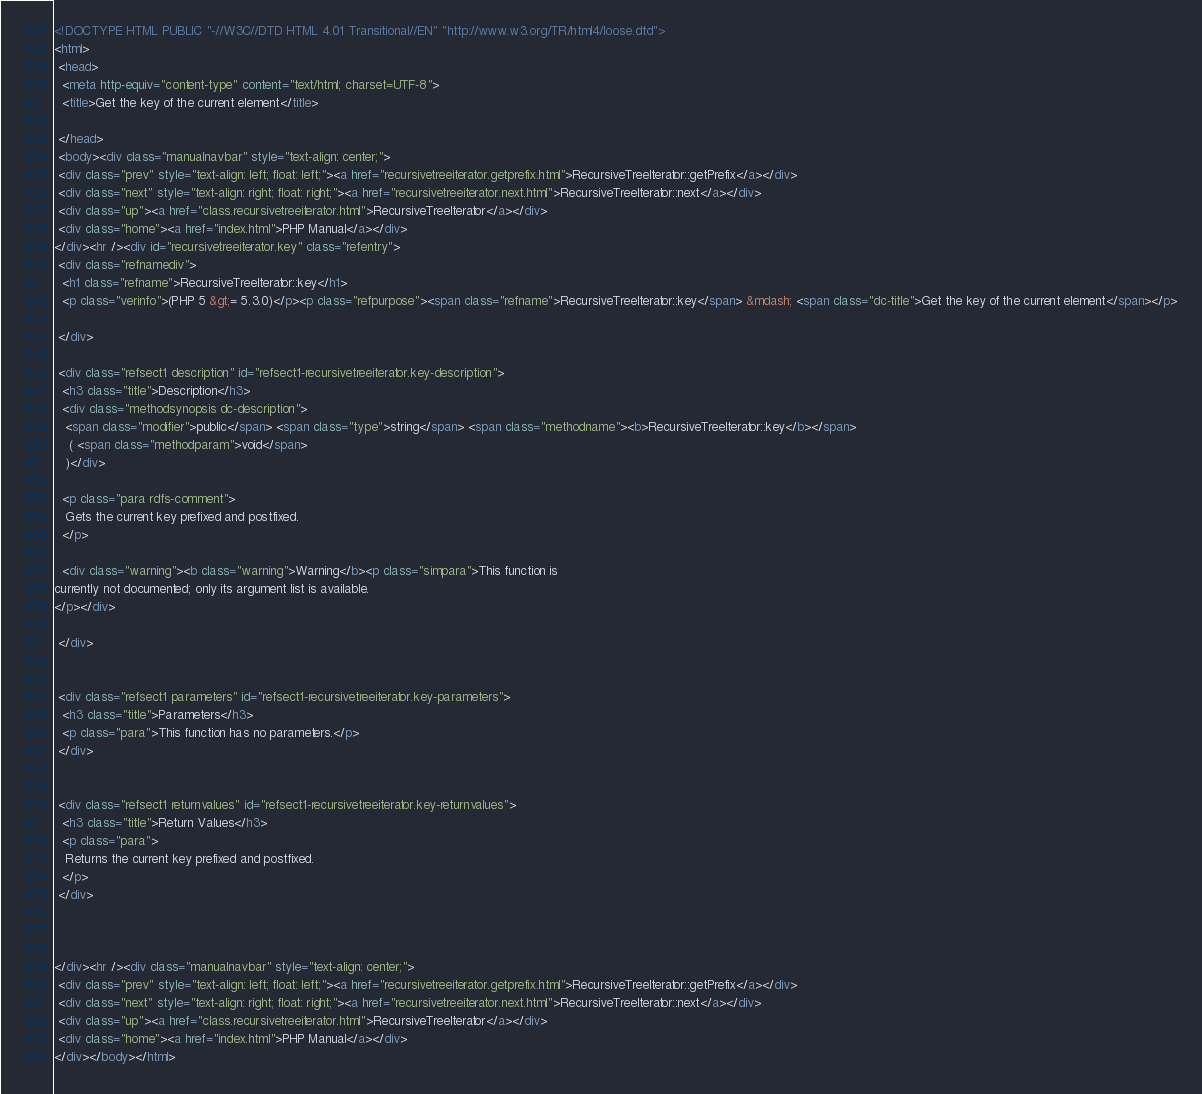Convert code to text. <code><loc_0><loc_0><loc_500><loc_500><_HTML_><!DOCTYPE HTML PUBLIC "-//W3C//DTD HTML 4.01 Transitional//EN" "http://www.w3.org/TR/html4/loose.dtd">
<html>
 <head>
  <meta http-equiv="content-type" content="text/html; charset=UTF-8">
  <title>Get the key of the current element</title>

 </head>
 <body><div class="manualnavbar" style="text-align: center;">
 <div class="prev" style="text-align: left; float: left;"><a href="recursivetreeiterator.getprefix.html">RecursiveTreeIterator::getPrefix</a></div>
 <div class="next" style="text-align: right; float: right;"><a href="recursivetreeiterator.next.html">RecursiveTreeIterator::next</a></div>
 <div class="up"><a href="class.recursivetreeiterator.html">RecursiveTreeIterator</a></div>
 <div class="home"><a href="index.html">PHP Manual</a></div>
</div><hr /><div id="recursivetreeiterator.key" class="refentry">
 <div class="refnamediv">
  <h1 class="refname">RecursiveTreeIterator::key</h1>
  <p class="verinfo">(PHP 5 &gt;= 5.3.0)</p><p class="refpurpose"><span class="refname">RecursiveTreeIterator::key</span> &mdash; <span class="dc-title">Get the key of the current element</span></p>

 </div>

 <div class="refsect1 description" id="refsect1-recursivetreeiterator.key-description">
  <h3 class="title">Description</h3>
  <div class="methodsynopsis dc-description">
   <span class="modifier">public</span> <span class="type">string</span> <span class="methodname"><b>RecursiveTreeIterator::key</b></span>
    ( <span class="methodparam">void</span>
   )</div>

  <p class="para rdfs-comment">
   Gets the current key prefixed and postfixed.
  </p>

  <div class="warning"><b class="warning">Warning</b><p class="simpara">This function is
currently not documented; only its argument list is available.
</p></div>

 </div>


 <div class="refsect1 parameters" id="refsect1-recursivetreeiterator.key-parameters">
  <h3 class="title">Parameters</h3>
  <p class="para">This function has no parameters.</p>
 </div>


 <div class="refsect1 returnvalues" id="refsect1-recursivetreeiterator.key-returnvalues">
  <h3 class="title">Return Values</h3>
  <p class="para">
   Returns the current key prefixed and postfixed.
  </p>
 </div>



</div><hr /><div class="manualnavbar" style="text-align: center;">
 <div class="prev" style="text-align: left; float: left;"><a href="recursivetreeiterator.getprefix.html">RecursiveTreeIterator::getPrefix</a></div>
 <div class="next" style="text-align: right; float: right;"><a href="recursivetreeiterator.next.html">RecursiveTreeIterator::next</a></div>
 <div class="up"><a href="class.recursivetreeiterator.html">RecursiveTreeIterator</a></div>
 <div class="home"><a href="index.html">PHP Manual</a></div>
</div></body></html>
</code> 